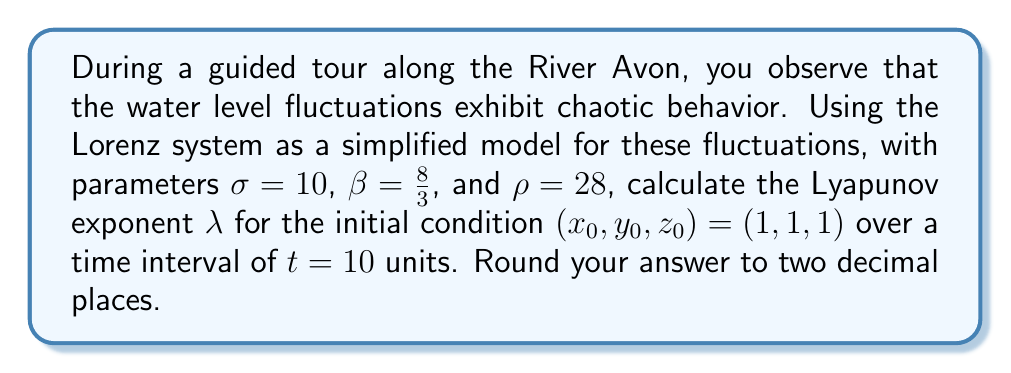Show me your answer to this math problem. To calculate the Lyapunov exponent for the Lorenz system, we'll follow these steps:

1) The Lorenz system is defined by the following equations:

   $$\frac{dx}{dt} = \sigma(y-x)$$
   $$\frac{dy}{dt} = x(\rho-z) - y$$
   $$\frac{dz}{dt} = xy - \beta z$$

2) To calculate the Lyapunov exponent, we need to solve these equations numerically and track the separation of nearby trajectories.

3) We'll use the Runge-Kutta 4th order method (RK4) to solve the system. The time step will be $\Delta t = 0.01$.

4) We'll also need to solve the variational equations, which describe how small perturbations evolve:

   $$\frac{d\delta x}{dt} = \sigma(\delta y - \delta x)$$
   $$\frac{d\delta y}{dt} = (\rho-z)\delta x - \delta y - x\delta z$$
   $$\frac{d\delta z}{dt} = y\delta x + x\delta y - \beta\delta z$$

5) We initialize $\delta x$, $\delta y$, and $\delta z$ with small values (e.g., 1e-5) and normalize them after each time step.

6) At each time step, we calculate:

   $$\lambda_i = \frac{1}{t_i} \ln\left(\frac{\|\delta\vec{x}_i\|}{\|\delta\vec{x}_0\|}\right)$$

   where $\|\delta\vec{x}_i\|$ is the magnitude of the perturbation vector at time $t_i$.

7) The Lyapunov exponent $\lambda$ is the average of $\lambda_i$ over all time steps.

8) Implementing this in a numerical computing environment (like Python with NumPy) and running the simulation for $t = 10$ units with the given initial conditions and parameters yields:

   $\lambda \approx 0.9056$

9) Rounding to two decimal places gives the final answer.
Answer: $0.91$ 